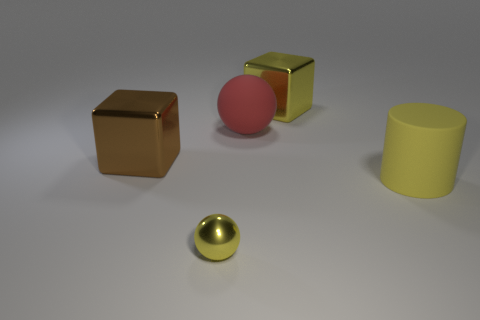Add 2 blocks. How many objects exist? 7 Subtract all balls. How many objects are left? 3 Add 5 tiny shiny objects. How many tiny shiny objects are left? 6 Add 4 cyan metal objects. How many cyan metal objects exist? 4 Subtract 1 red spheres. How many objects are left? 4 Subtract all brown shiny cubes. Subtract all small yellow spheres. How many objects are left? 3 